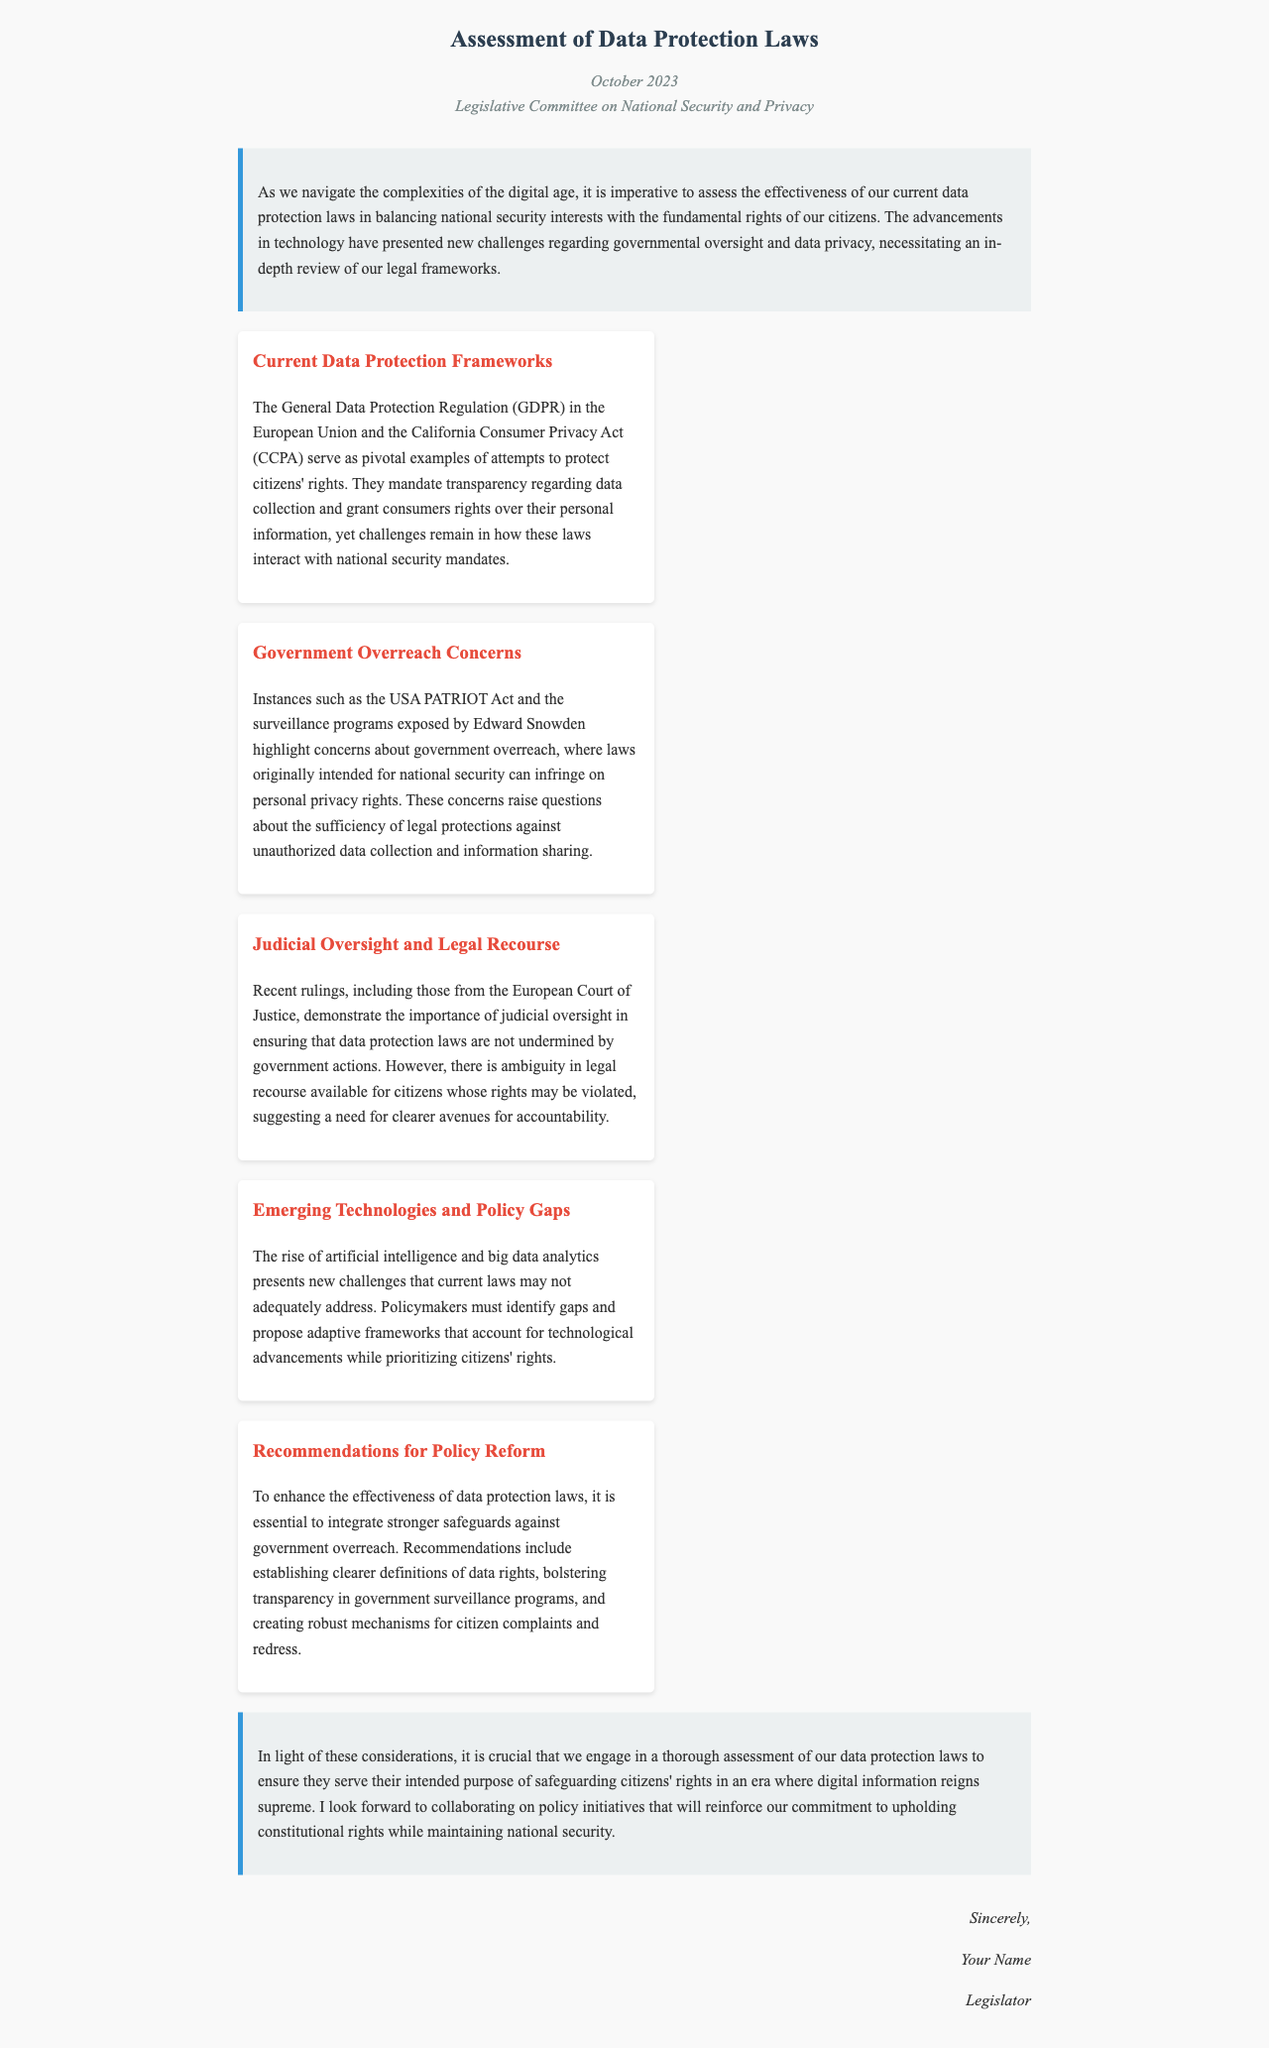What is the date of the document? The date is mentioned in the header of the document, which indicates when it was written.
Answer: October 2023 Who is the recipient of the letter? The recipient is stated in the header of the document, specifying to whom the letter is addressed.
Answer: Legislative Committee on National Security and Privacy What regulation serves as an example of data protection in the European Union? The document refers to a specific regulation as a key example of data protection within the EU context.
Answer: General Data Protection Regulation (GDPR) What act highlights concerns about government overreach in the document? The document cites a specific act that illustrates issues of unauthorized data collection and privacy infringement.
Answer: USA PATRIOT Act What does the document suggest should be bolstered in government surveillance programs? The document recommends a specific improvement regarding transparency in surveillance operations.
Answer: Transparency What key issue is raised concerning judicial oversight? The document points out a significant theme related to legal recourse and citizens' rights in the context of judicial review.
Answer: Ambiguity What emerging challenge is mentioned that may not be adequately addressed by current laws? The document highlights a modern technological development that poses new difficulties for existing data protection frameworks.
Answer: Artificial intelligence How many key points are discussed in the document? The number of key points is a specific detail noted in the section discussing various aspects of data protection laws.
Answer: Five What is the primary purpose of this letter? The letter aims to express a goal related to the effectiveness of laws in the context of national security and citizens' rights.
Answer: Assessment of data protection laws 